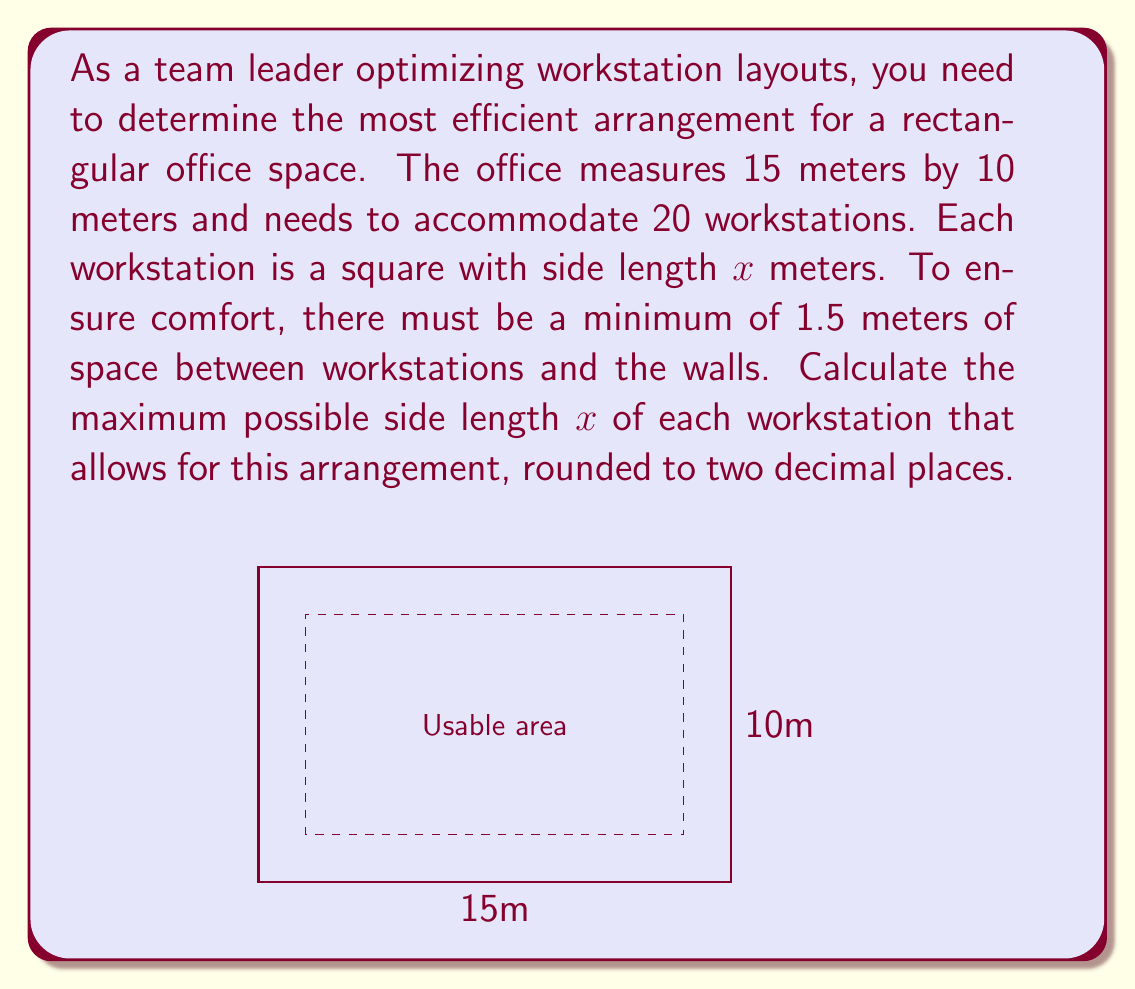Can you answer this question? To solve this problem, we'll follow these steps:

1) First, let's calculate the usable area of the office after accounting for the 1.5m buffer zone around the edges:
   Usable width = $15 - (2 * 1.5) = 12$ meters
   Usable height = $10 - (2 * 1.5) = 7$ meters
   Usable area = $12 * 7 = 84$ square meters

2) Now, we need to fit 20 square workstations into this 84 square meter area. Let $x$ be the side length of each workstation. The total area occupied by the workstations must be less than or equal to the usable area:

   $$20x^2 \leq 84$$

3) Solving for $x$:
   $$x^2 \leq \frac{84}{20} = 4.2$$
   $$x \leq \sqrt{4.2} \approx 2.0494$$

4) Therefore, the maximum side length of each workstation can be 2.04 meters (rounded to two decimal places).

5) To verify, let's check if 20 workstations of this size can fit in the usable area:
   $20 * (2.04)^2 = 83.2316$ square meters, which is indeed less than 84 square meters.

This solution ensures that each team member has a comfortable workstation while maximizing the use of available space.
Answer: The maximum possible side length of each workstation is $2.04$ meters. 